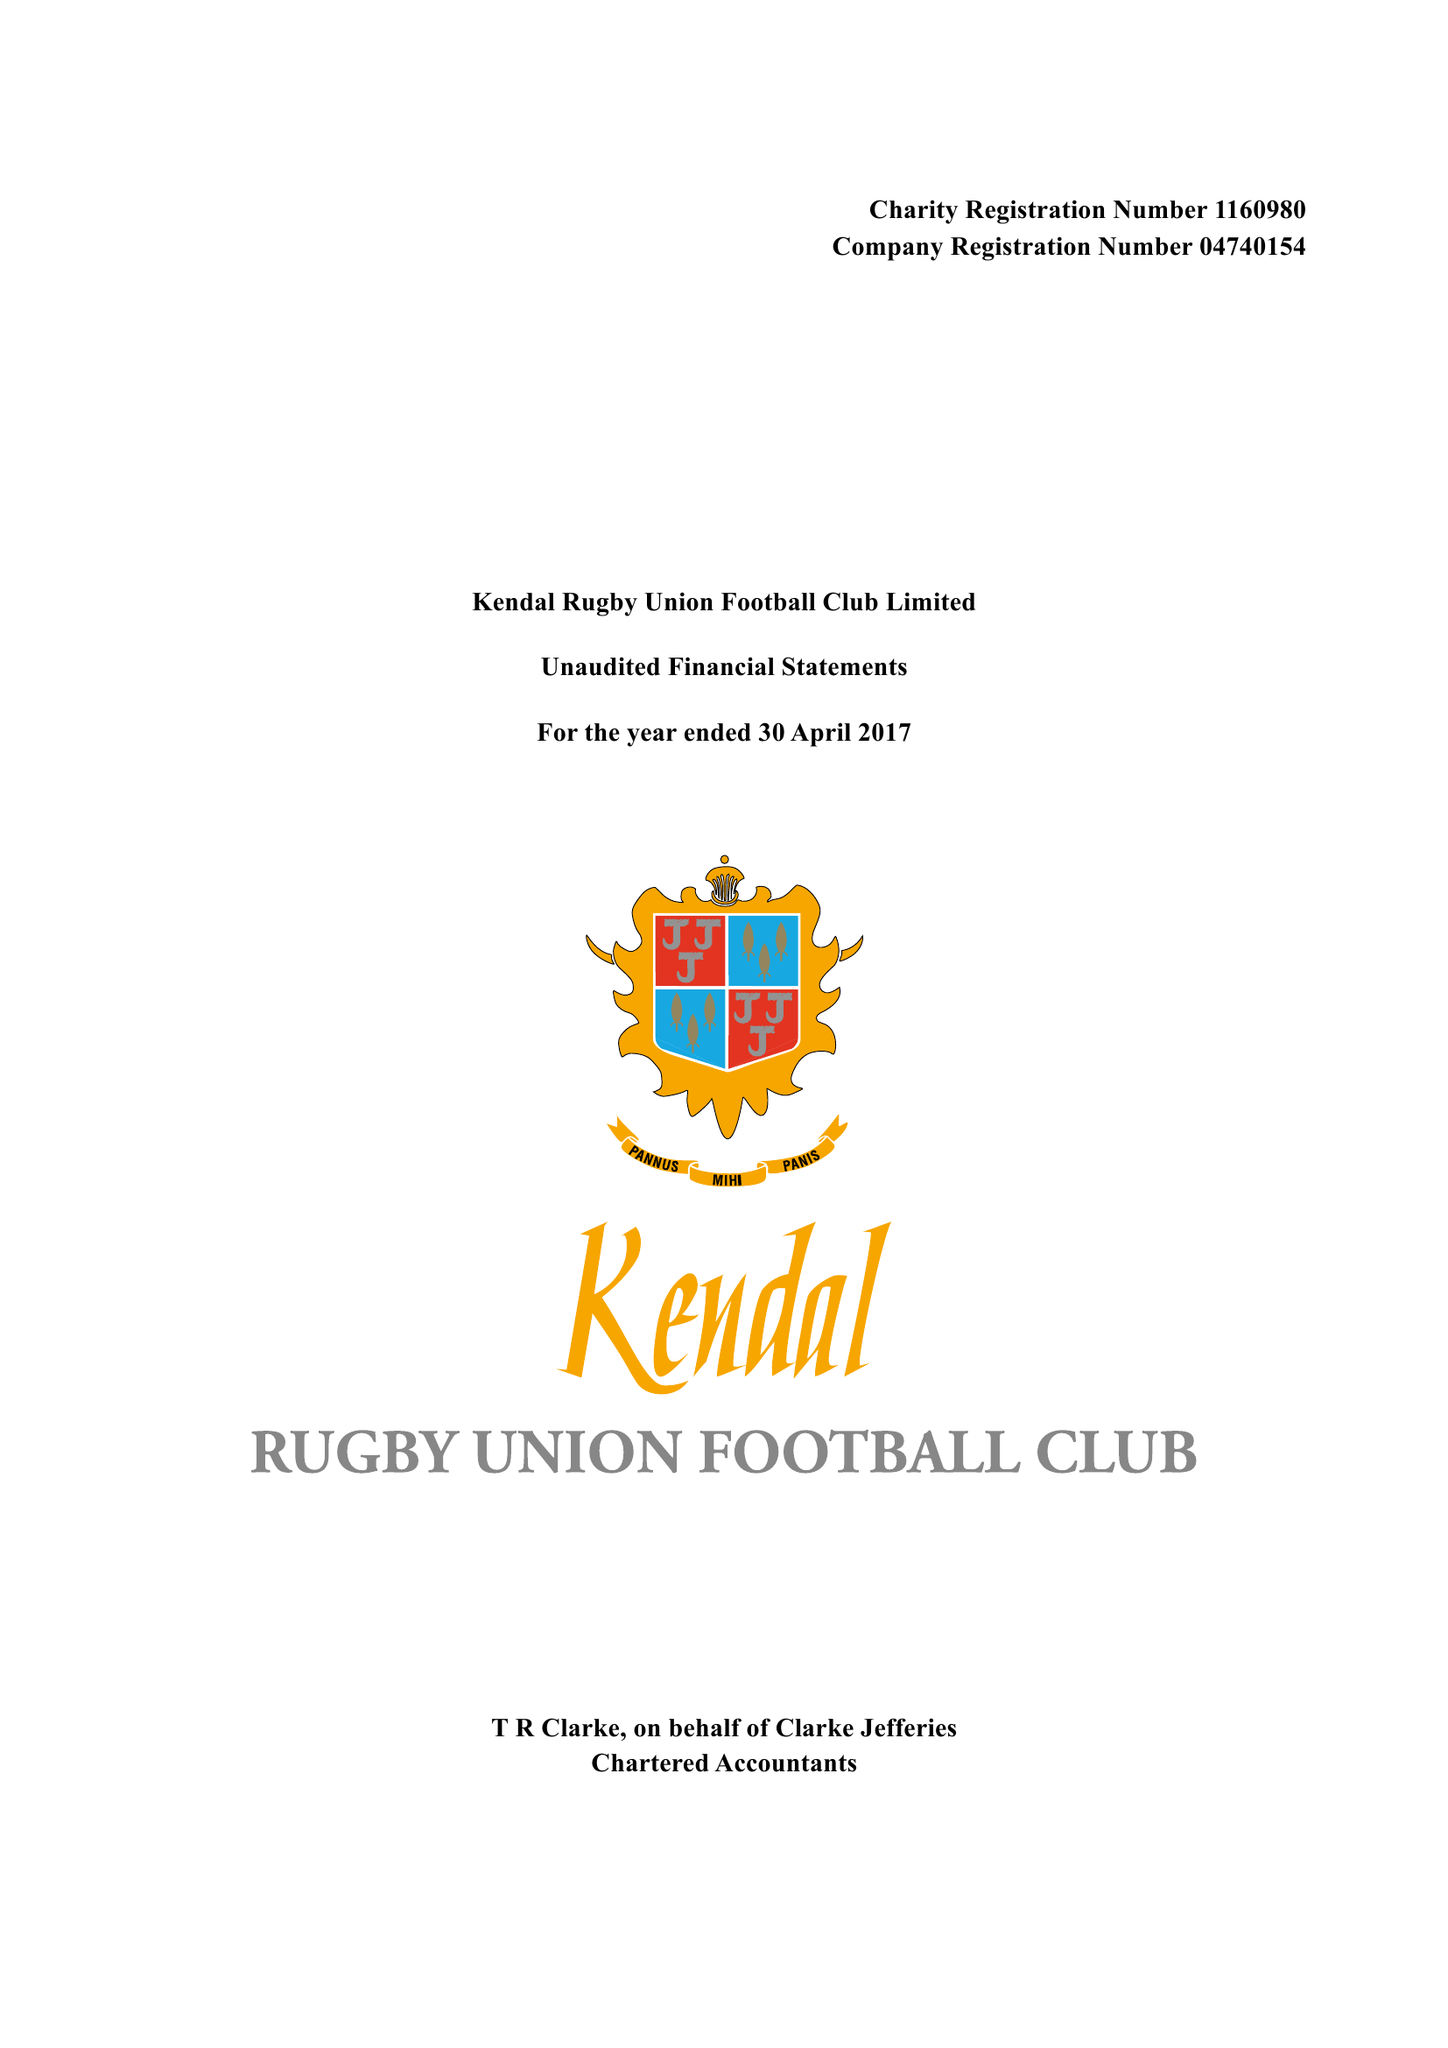What is the value for the address__postcode?
Answer the question using a single word or phrase. LA9 6NY 